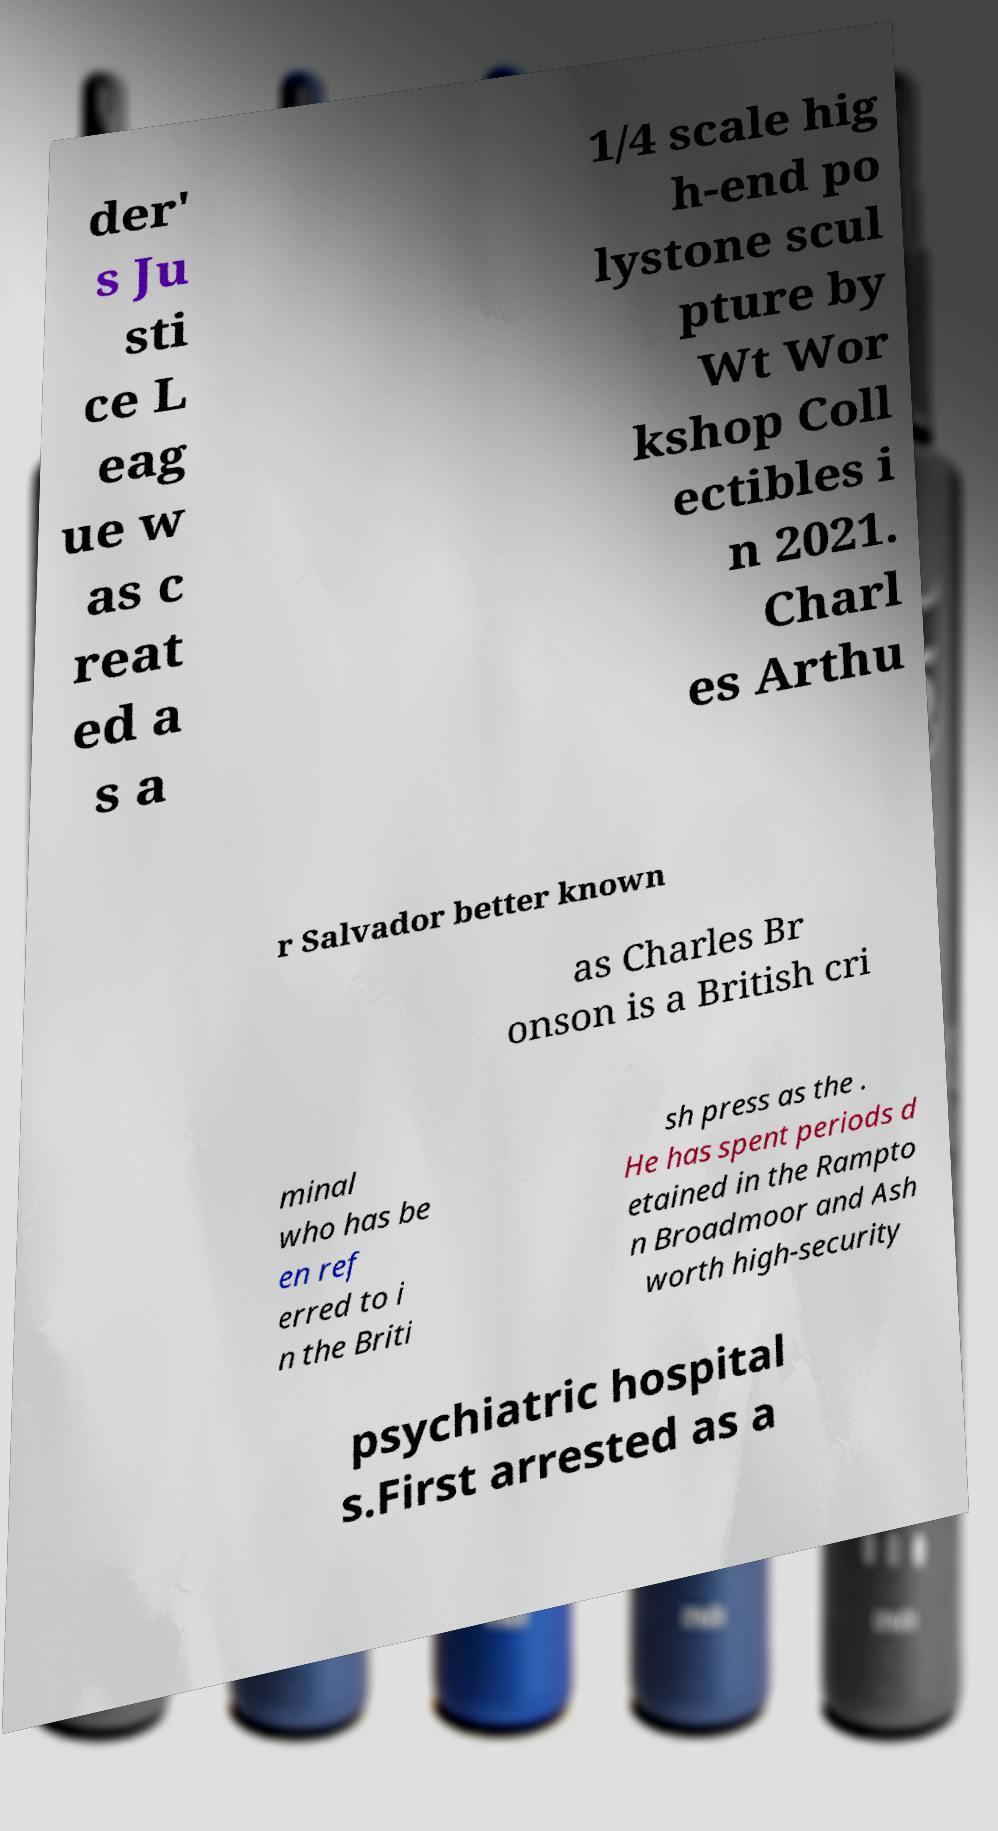I need the written content from this picture converted into text. Can you do that? der' s Ju sti ce L eag ue w as c reat ed a s a 1/4 scale hig h-end po lystone scul pture by Wt Wor kshop Coll ectibles i n 2021. Charl es Arthu r Salvador better known as Charles Br onson is a British cri minal who has be en ref erred to i n the Briti sh press as the . He has spent periods d etained in the Rampto n Broadmoor and Ash worth high-security psychiatric hospital s.First arrested as a 